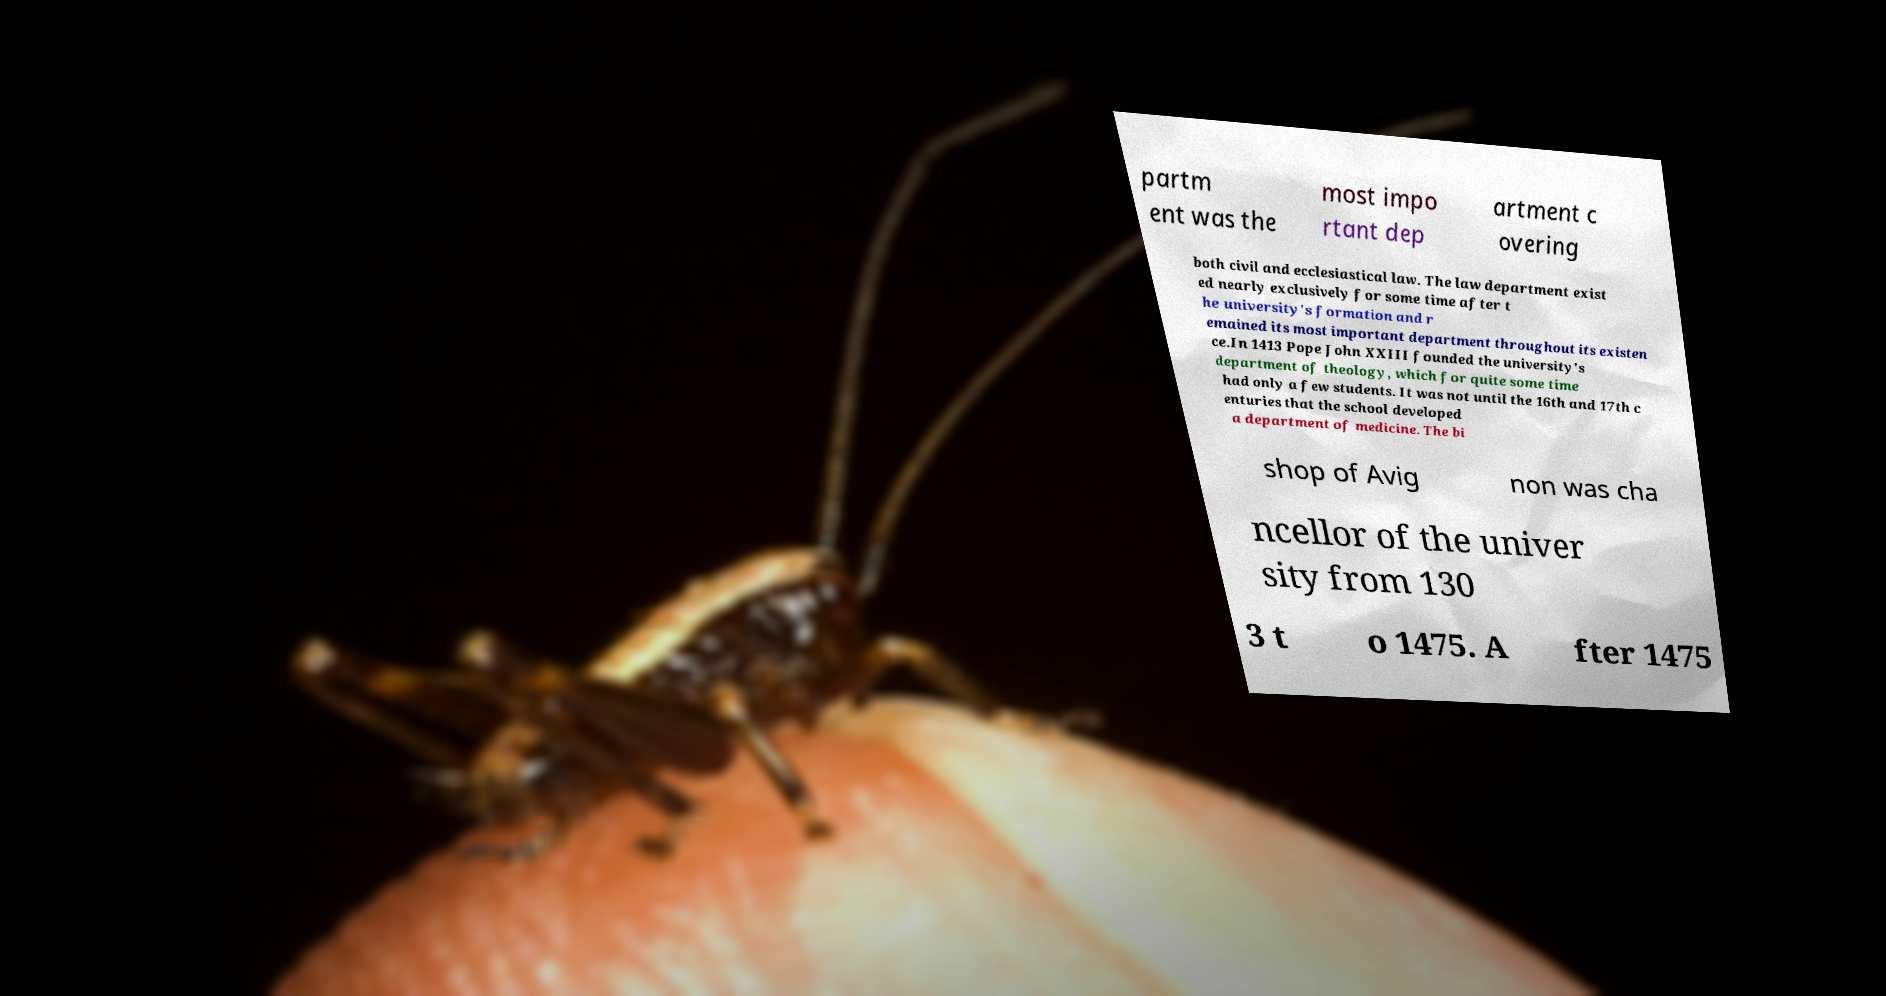Can you read and provide the text displayed in the image?This photo seems to have some interesting text. Can you extract and type it out for me? partm ent was the most impo rtant dep artment c overing both civil and ecclesiastical law. The law department exist ed nearly exclusively for some time after t he university's formation and r emained its most important department throughout its existen ce.In 1413 Pope John XXIII founded the university's department of theology, which for quite some time had only a few students. It was not until the 16th and 17th c enturies that the school developed a department of medicine. The bi shop of Avig non was cha ncellor of the univer sity from 130 3 t o 1475. A fter 1475 